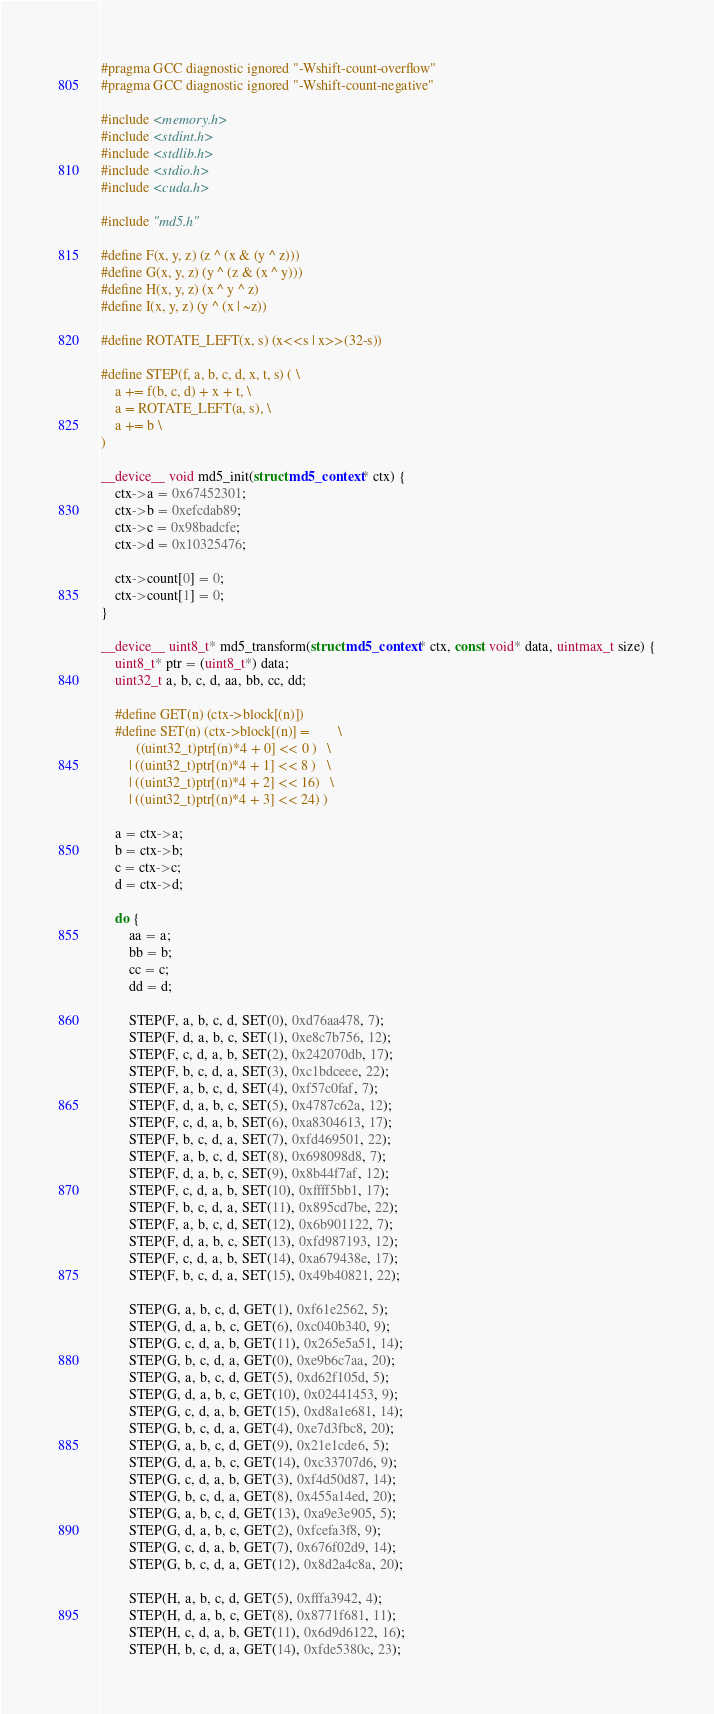<code> <loc_0><loc_0><loc_500><loc_500><_Cuda_>#pragma GCC diagnostic ignored "-Wshift-count-overflow"
#pragma GCC diagnostic ignored "-Wshift-count-negative"

#include <memory.h>
#include <stdint.h>
#include <stdlib.h>
#include <stdio.h>
#include <cuda.h>

#include "md5.h"

#define F(x, y, z) (z ^ (x & (y ^ z)))
#define G(x, y, z) (y ^ (z & (x ^ y)))
#define H(x, y, z) (x ^ y ^ z)
#define I(x, y, z) (y ^ (x | ~z))

#define ROTATE_LEFT(x, s) (x<<s | x>>(32-s))

#define STEP(f, a, b, c, d, x, t, s) ( \
    a += f(b, c, d) + x + t, \
    a = ROTATE_LEFT(a, s), \
    a += b \
)

__device__ void md5_init(struct md5_context* ctx) {
    ctx->a = 0x67452301;
    ctx->b = 0xefcdab89;
    ctx->c = 0x98badcfe;
    ctx->d = 0x10325476;

    ctx->count[0] = 0;
    ctx->count[1] = 0;
}

__device__ uint8_t* md5_transform(struct md5_context* ctx, const void* data, uintmax_t size) {
    uint8_t* ptr = (uint8_t*) data;
    uint32_t a, b, c, d, aa, bb, cc, dd;

    #define GET(n) (ctx->block[(n)])
    #define SET(n) (ctx->block[(n)] =        \
          ((uint32_t)ptr[(n)*4 + 0] << 0 )   \
        | ((uint32_t)ptr[(n)*4 + 1] << 8 )   \
        | ((uint32_t)ptr[(n)*4 + 2] << 16)   \
        | ((uint32_t)ptr[(n)*4 + 3] << 24) )

    a = ctx->a;
    b = ctx->b;
    c = ctx->c;
    d = ctx->d;

    do {
        aa = a;
        bb = b;
        cc = c; 
        dd = d;

        STEP(F, a, b, c, d, SET(0), 0xd76aa478, 7);
        STEP(F, d, a, b, c, SET(1), 0xe8c7b756, 12);
        STEP(F, c, d, a, b, SET(2), 0x242070db, 17);
        STEP(F, b, c, d, a, SET(3), 0xc1bdceee, 22);
        STEP(F, a, b, c, d, SET(4), 0xf57c0faf, 7);
        STEP(F, d, a, b, c, SET(5), 0x4787c62a, 12);
        STEP(F, c, d, a, b, SET(6), 0xa8304613, 17);
        STEP(F, b, c, d, a, SET(7), 0xfd469501, 22);
        STEP(F, a, b, c, d, SET(8), 0x698098d8, 7);
        STEP(F, d, a, b, c, SET(9), 0x8b44f7af, 12);
        STEP(F, c, d, a, b, SET(10), 0xffff5bb1, 17);
        STEP(F, b, c, d, a, SET(11), 0x895cd7be, 22);
        STEP(F, a, b, c, d, SET(12), 0x6b901122, 7);
        STEP(F, d, a, b, c, SET(13), 0xfd987193, 12);
        STEP(F, c, d, a, b, SET(14), 0xa679438e, 17);
        STEP(F, b, c, d, a, SET(15), 0x49b40821, 22);

        STEP(G, a, b, c, d, GET(1), 0xf61e2562, 5);
        STEP(G, d, a, b, c, GET(6), 0xc040b340, 9);
        STEP(G, c, d, a, b, GET(11), 0x265e5a51, 14);
        STEP(G, b, c, d, a, GET(0), 0xe9b6c7aa, 20);
        STEP(G, a, b, c, d, GET(5), 0xd62f105d, 5);
        STEP(G, d, a, b, c, GET(10), 0x02441453, 9);
        STEP(G, c, d, a, b, GET(15), 0xd8a1e681, 14);
        STEP(G, b, c, d, a, GET(4), 0xe7d3fbc8, 20);
        STEP(G, a, b, c, d, GET(9), 0x21e1cde6, 5);
        STEP(G, d, a, b, c, GET(14), 0xc33707d6, 9);
        STEP(G, c, d, a, b, GET(3), 0xf4d50d87, 14);
        STEP(G, b, c, d, a, GET(8), 0x455a14ed, 20);
        STEP(G, a, b, c, d, GET(13), 0xa9e3e905, 5);
        STEP(G, d, a, b, c, GET(2), 0xfcefa3f8, 9);
        STEP(G, c, d, a, b, GET(7), 0x676f02d9, 14);
        STEP(G, b, c, d, a, GET(12), 0x8d2a4c8a, 20);

        STEP(H, a, b, c, d, GET(5), 0xfffa3942, 4);
        STEP(H, d, a, b, c, GET(8), 0x8771f681, 11);
        STEP(H, c, d, a, b, GET(11), 0x6d9d6122, 16);
        STEP(H, b, c, d, a, GET(14), 0xfde5380c, 23);</code> 